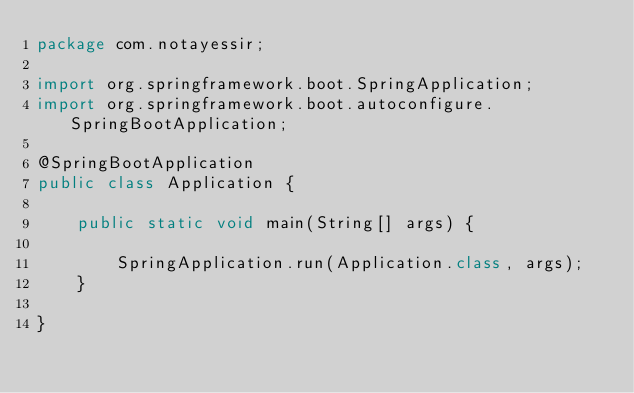<code> <loc_0><loc_0><loc_500><loc_500><_Java_>package com.notayessir;

import org.springframework.boot.SpringApplication;
import org.springframework.boot.autoconfigure.SpringBootApplication;

@SpringBootApplication
public class Application {

    public static void main(String[] args) {

        SpringApplication.run(Application.class, args);
    }

}

</code> 